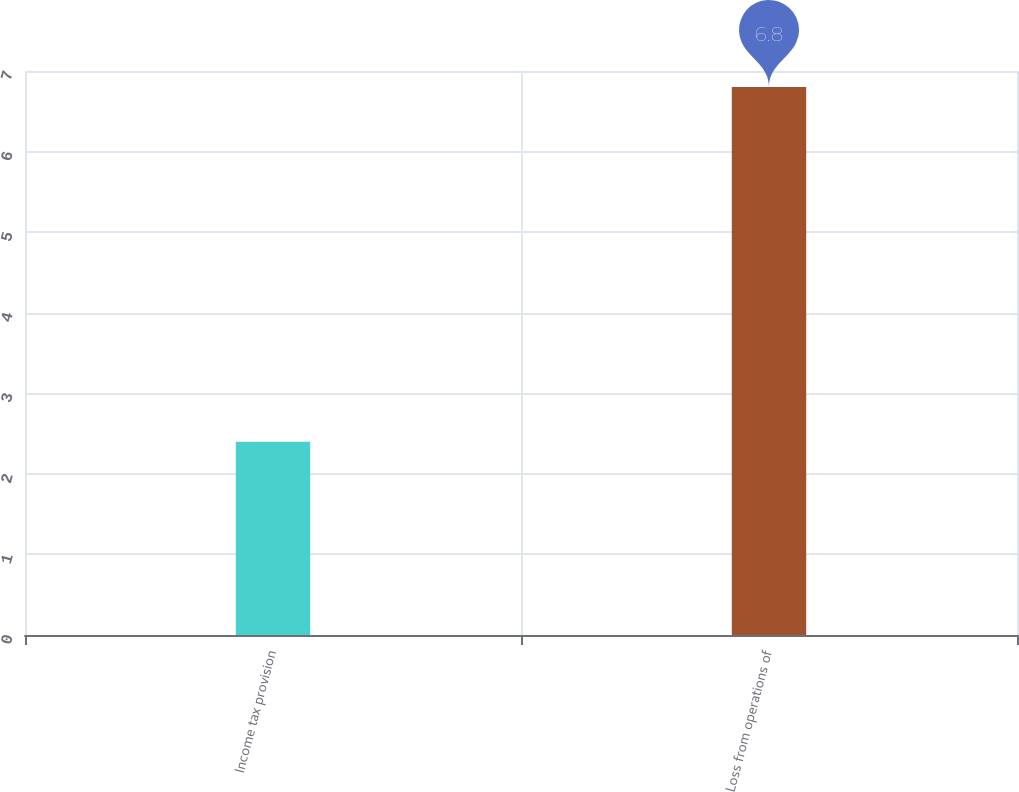Convert chart. <chart><loc_0><loc_0><loc_500><loc_500><bar_chart><fcel>Income tax provision<fcel>Loss from operations of<nl><fcel>2.4<fcel>6.8<nl></chart> 